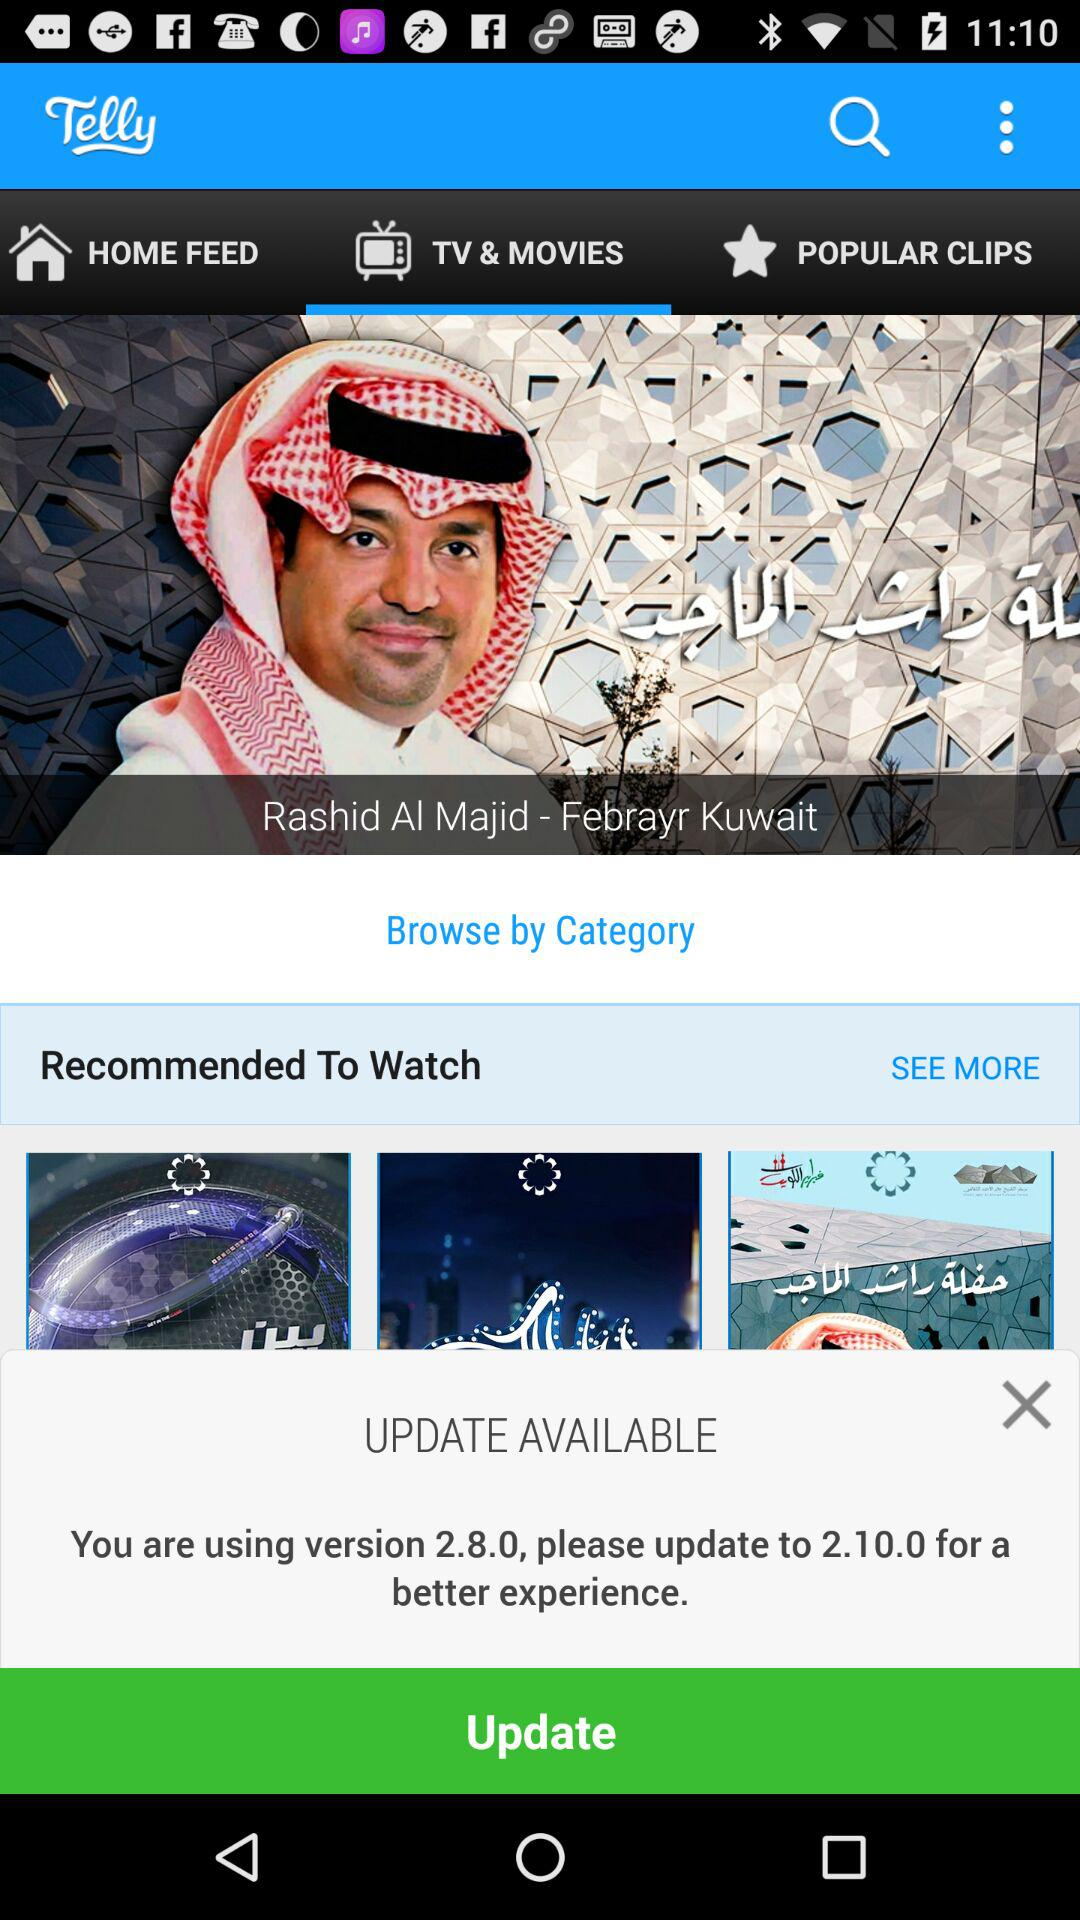Which tab is selected? The selected tab is "TV & MOVIES". 